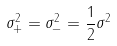Convert formula to latex. <formula><loc_0><loc_0><loc_500><loc_500>\sigma _ { + } ^ { 2 } = \sigma _ { - } ^ { 2 } = \frac { 1 } { 2 } \sigma ^ { 2 }</formula> 